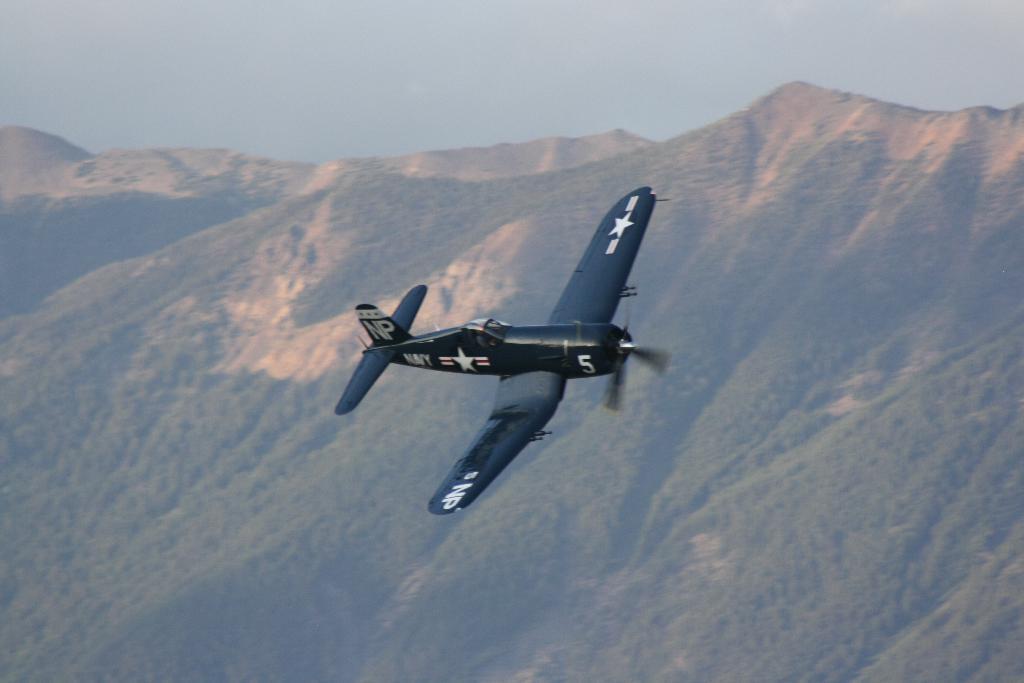Please provide a concise description of this image. In this image I can see an aircraft in the air. In the background I can see the mountains and the sky. 